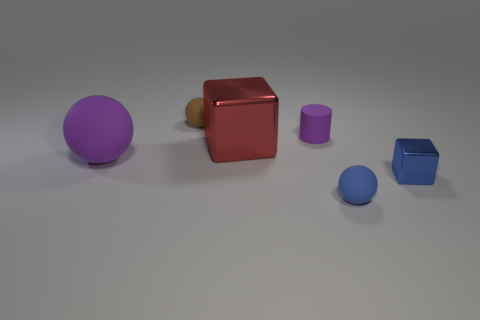There is a thing that is to the right of the large shiny object and behind the purple matte ball; what is it made of?
Your answer should be compact. Rubber. There is a blue block that is in front of the purple ball; is there a big rubber object that is in front of it?
Your answer should be compact. No. How many matte cylinders have the same color as the large rubber thing?
Provide a succinct answer. 1. What material is the other thing that is the same color as the small metallic thing?
Your response must be concise. Rubber. Is the material of the large red object the same as the small cylinder?
Provide a short and direct response. No. There is a big shiny block; are there any purple spheres behind it?
Make the answer very short. No. The tiny ball that is left of the shiny object that is behind the blue cube is made of what material?
Ensure brevity in your answer.  Rubber. There is a purple thing that is the same shape as the blue rubber object; what size is it?
Provide a succinct answer. Large. Does the big shiny thing have the same color as the small cylinder?
Your answer should be compact. No. The tiny thing that is both on the left side of the blue shiny block and to the right of the small purple rubber cylinder is what color?
Your answer should be compact. Blue. 